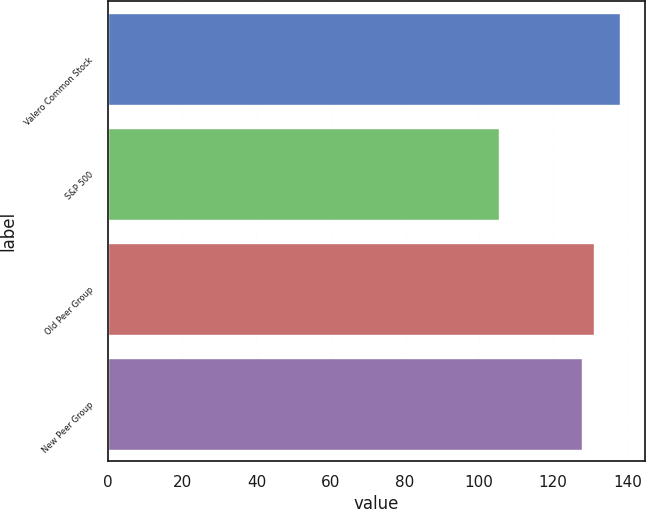Convert chart to OTSL. <chart><loc_0><loc_0><loc_500><loc_500><bar_chart><fcel>Valero Common Stock<fcel>S&P 500<fcel>Old Peer Group<fcel>New Peer Group<nl><fcel>137.91<fcel>105.49<fcel>131.16<fcel>127.92<nl></chart> 